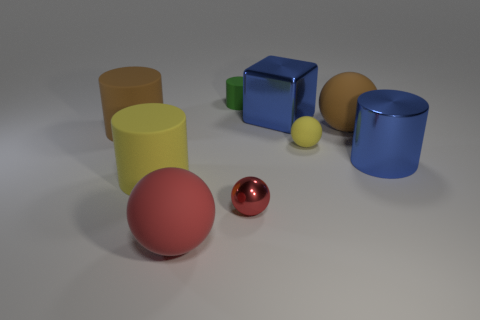Subtract 1 cylinders. How many cylinders are left? 3 Subtract all gray balls. Subtract all purple cylinders. How many balls are left? 4 Subtract all blocks. How many objects are left? 8 Add 1 metal cubes. How many metal cubes are left? 2 Add 1 blue objects. How many blue objects exist? 3 Subtract 0 purple spheres. How many objects are left? 9 Subtract all gray shiny blocks. Subtract all small metallic things. How many objects are left? 8 